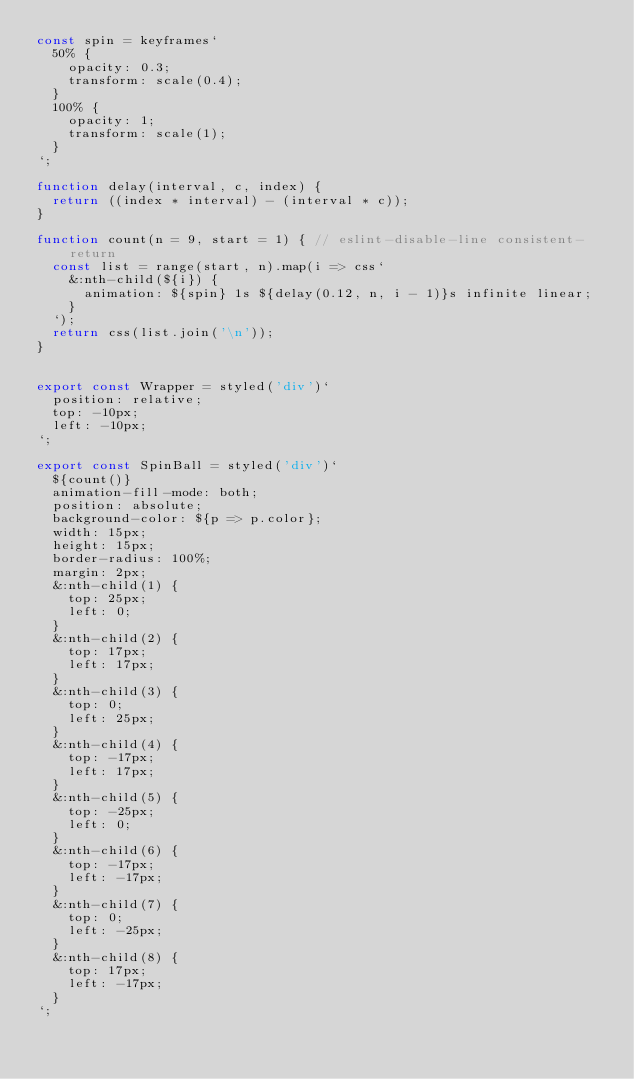Convert code to text. <code><loc_0><loc_0><loc_500><loc_500><_JavaScript_>const spin = keyframes`
  50% {
    opacity: 0.3;
    transform: scale(0.4);
  }
  100% {
    opacity: 1;
    transform: scale(1);
  }
`;

function delay(interval, c, index) {
  return ((index * interval) - (interval * c));
}

function count(n = 9, start = 1) { // eslint-disable-line consistent-return
  const list = range(start, n).map(i => css`
    &:nth-child(${i}) {
      animation: ${spin} 1s ${delay(0.12, n, i - 1)}s infinite linear;
    }
  `);
  return css(list.join('\n'));
}


export const Wrapper = styled('div')`
  position: relative;
  top: -10px;
  left: -10px;
`;

export const SpinBall = styled('div')`
  ${count()}
  animation-fill-mode: both;
  position: absolute;
  background-color: ${p => p.color};
  width: 15px;
  height: 15px;
  border-radius: 100%;
  margin: 2px;
  &:nth-child(1) {
    top: 25px;
    left: 0;
  }
  &:nth-child(2) {
    top: 17px;
    left: 17px;
  }
  &:nth-child(3) {
    top: 0;
    left: 25px;
  }
  &:nth-child(4) {
    top: -17px;
    left: 17px;
  }
  &:nth-child(5) {
    top: -25px;
    left: 0;
  }
  &:nth-child(6) {
    top: -17px;
    left: -17px;
  }
  &:nth-child(7) {
    top: 0;
    left: -25px;
  }
  &:nth-child(8) {
    top: 17px;
    left: -17px;
  }
`;
</code> 